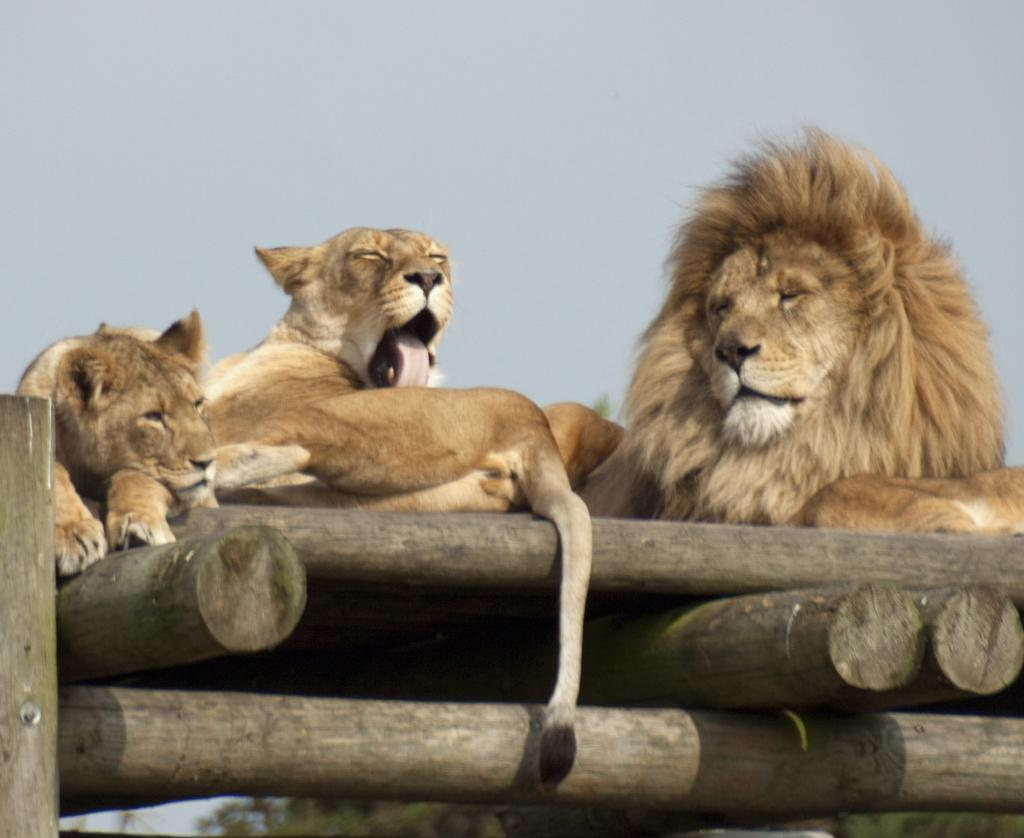What type of animal is the main subject in the image? There is a lion in the image. Are there any other animals present in the image? Yes, there are lion babies in the image. What are the lion and lion babies laying on in the image? The lion and lion babies are laying on wooden poles. What type of gate can be seen in the image? There is no gate present in the image; it features a lion and lion babies laying on wooden poles. What type of nut is being cracked by the lion in the image? There is no nut present in the image, nor is the lion shown cracking any nut. 